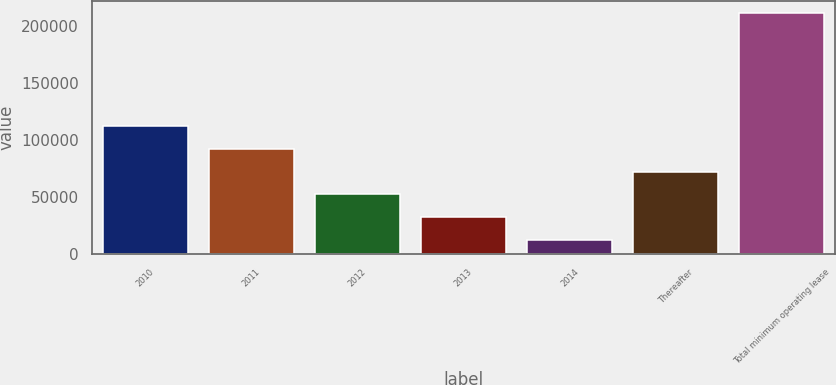Convert chart. <chart><loc_0><loc_0><loc_500><loc_500><bar_chart><fcel>2010<fcel>2011<fcel>2012<fcel>2013<fcel>2014<fcel>Thereafter<fcel>Total minimum operating lease<nl><fcel>112255<fcel>92370.4<fcel>52601.2<fcel>32716.6<fcel>12832<fcel>72485.8<fcel>211678<nl></chart> 